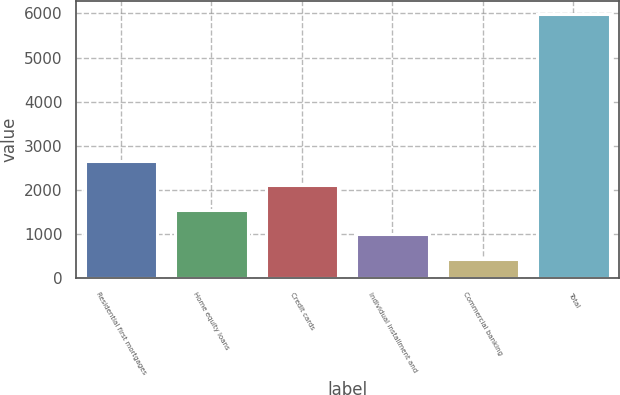Convert chart. <chart><loc_0><loc_0><loc_500><loc_500><bar_chart><fcel>Residential first mortgages<fcel>Home equity loans<fcel>Credit cards<fcel>Individual installment and<fcel>Commercial banking<fcel>Total<nl><fcel>2652.4<fcel>1542.2<fcel>2097.3<fcel>987.1<fcel>432<fcel>5983<nl></chart> 